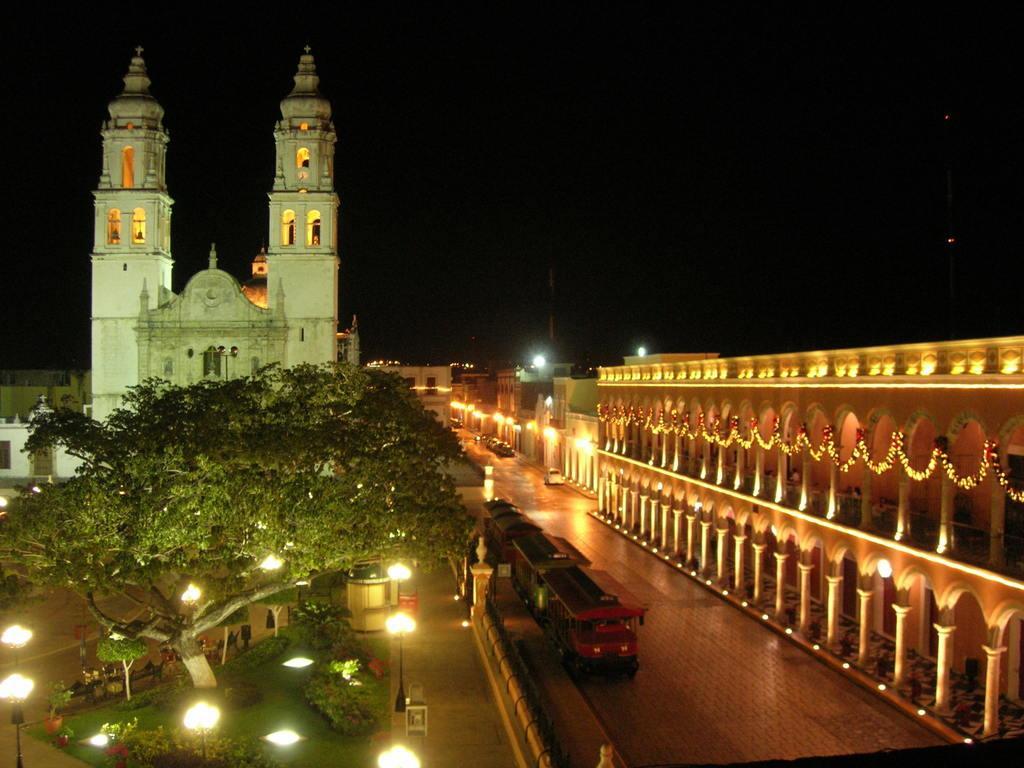Please provide a concise description of this image. In this picture we can see buildings with lights. In front of the buildings there is a tree, vehicles on the path and on the left side of the vehicles there are poles with lights and plants. Behind the buildings there is a dark background. 